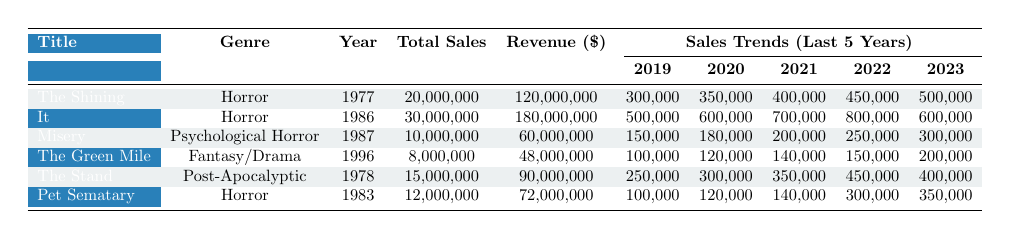What is the title of the Stephen King book with the highest total sales? To find the title with the highest total sales, we examine the "Total Sales" column. The highest value is 30,000,000, which corresponds to the book "It".
Answer: It Which book has the lowest revenue? In the "Revenue" column, we look for the smallest value. The lowest revenue is 48,000,000, associated with "The Green Mile".
Answer: The Green Mile What are the total sales of "Misery"? Referring to the "Total Sales" column for "Misery", we see it has 10,000,000 total sales.
Answer: 10,000,000 Which genre has the most books listed in the table? By reviewing the "Genre" column, we see that "Horror" appears most frequently, listed for three different books: "The Shining", "It", and "Pet Sematary".
Answer: Horror What was the sales trend for "The Stand" from 2019 to 2023? Checking the sales figures for "The Stand", the values are as follows: 250,000 in 2019, increasing to 350,000 in 2021, peaking at 450,000 in 2022, and then declining to 400,000 in 2023.
Answer: Decreasing trend Calculate the average revenue of the books in the "Horror" genre. The revenues for the Horror genre books are: "The Shining" - 120,000,000, "It" - 180,000,000, and "Pet Sematary" - 72,000,000. Total revenue = 120 + 180 + 72 = 372 million and average revenue = 372 / 3 = 124 million.
Answer: 124,000,000 Did "It" have a higher current year sales than "The Shining"? "It" has current year sales of 600,000, while "The Shining" has 500,000. Therefore, "It" had higher current year sales.
Answer: Yes What was the revenue difference between "The Shining" and "Pet Sematary"? The revenue for "The Shining" is 120,000,000 and for "Pet Sematary" it is 72,000,000. The difference is 120 - 72 = 48 million.
Answer: 48,000,000 Which book had the most sales in 2020? Looking at the sales figures for 2020, "It" had the highest sales figure of 600,000, compared to other books.
Answer: It How many books have been published after 1990? By examining the "Published Year" column, only "The Green Mile" (1996) fits; thus there is only one book published after 1990.
Answer: 1 What was the trend for "Misery" over the last five years? Sales for "Misery" increased each year: 150,000 in 2019, 180,000 in 2020, 200,000 in 2021, 250,000 in 2022, and 300,000 in 2023, indicating a consistent upward trend.
Answer: Upward trend 